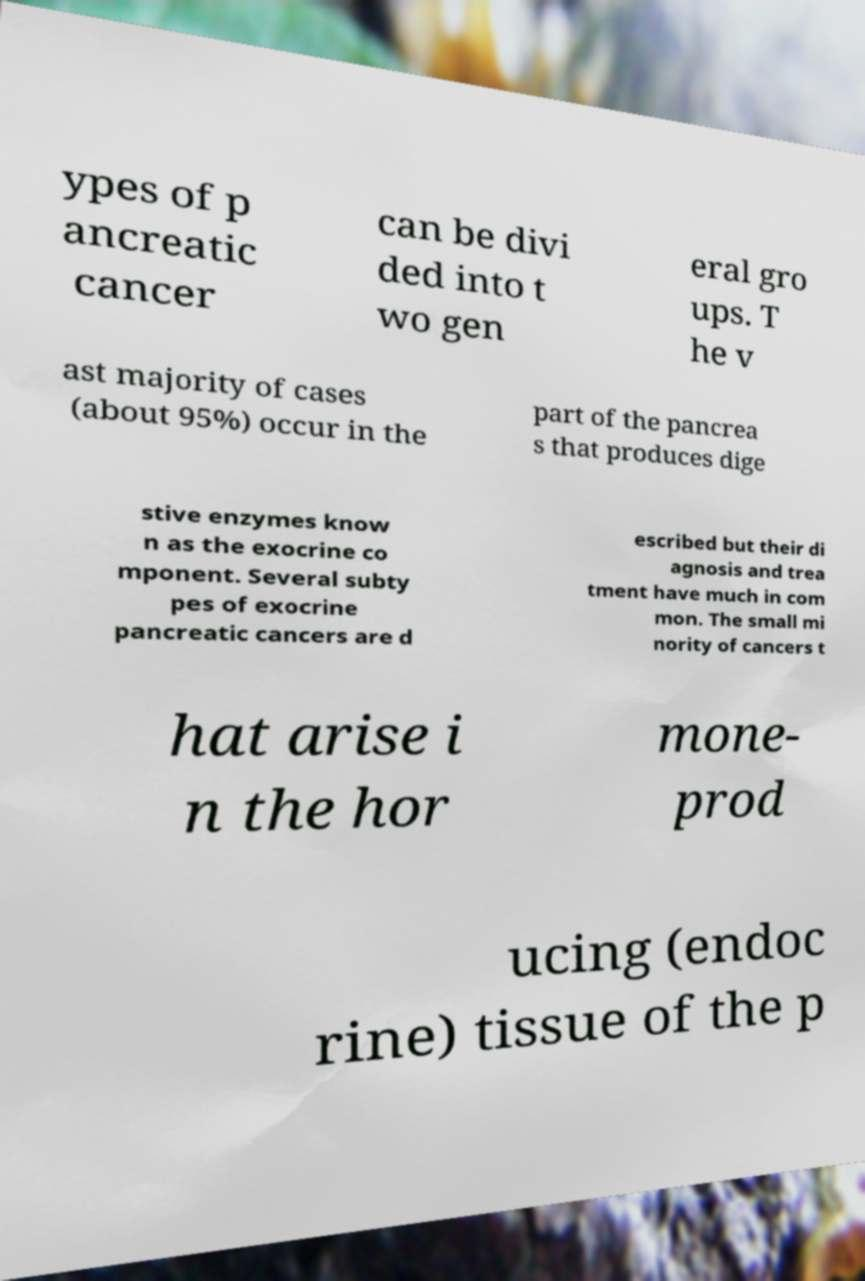Can you accurately transcribe the text from the provided image for me? ypes of p ancreatic cancer can be divi ded into t wo gen eral gro ups. T he v ast majority of cases (about 95%) occur in the part of the pancrea s that produces dige stive enzymes know n as the exocrine co mponent. Several subty pes of exocrine pancreatic cancers are d escribed but their di agnosis and trea tment have much in com mon. The small mi nority of cancers t hat arise i n the hor mone- prod ucing (endoc rine) tissue of the p 